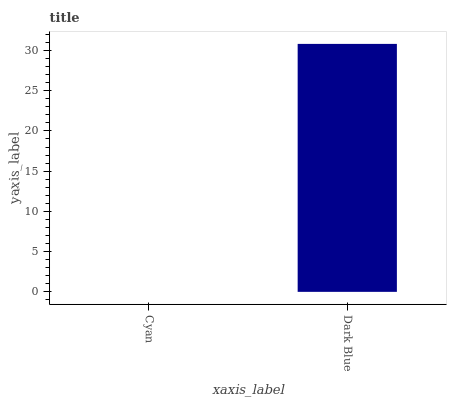Is Cyan the minimum?
Answer yes or no. Yes. Is Dark Blue the maximum?
Answer yes or no. Yes. Is Dark Blue the minimum?
Answer yes or no. No. Is Dark Blue greater than Cyan?
Answer yes or no. Yes. Is Cyan less than Dark Blue?
Answer yes or no. Yes. Is Cyan greater than Dark Blue?
Answer yes or no. No. Is Dark Blue less than Cyan?
Answer yes or no. No. Is Dark Blue the high median?
Answer yes or no. Yes. Is Cyan the low median?
Answer yes or no. Yes. Is Cyan the high median?
Answer yes or no. No. Is Dark Blue the low median?
Answer yes or no. No. 